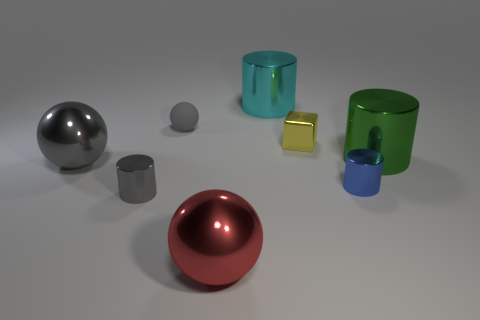There is a small metallic thing on the left side of the cyan object; is its shape the same as the tiny gray thing behind the yellow cube?
Your response must be concise. No. What number of big cyan metallic cylinders are in front of the large green metal cylinder?
Provide a short and direct response. 0. Is there a tiny cube made of the same material as the small gray sphere?
Provide a succinct answer. No. What material is the blue cylinder that is the same size as the yellow shiny object?
Ensure brevity in your answer.  Metal. Is the material of the yellow thing the same as the small gray cylinder?
Provide a succinct answer. Yes. What number of things are either large gray balls or small yellow metallic things?
Offer a terse response. 2. There is a big object that is to the left of the matte thing; what shape is it?
Your answer should be compact. Sphere. There is a block that is the same material as the gray cylinder; what is its color?
Give a very brief answer. Yellow. There is a small gray object that is the same shape as the large gray shiny object; what is it made of?
Offer a terse response. Rubber. There is a small yellow thing; what shape is it?
Keep it short and to the point. Cube. 